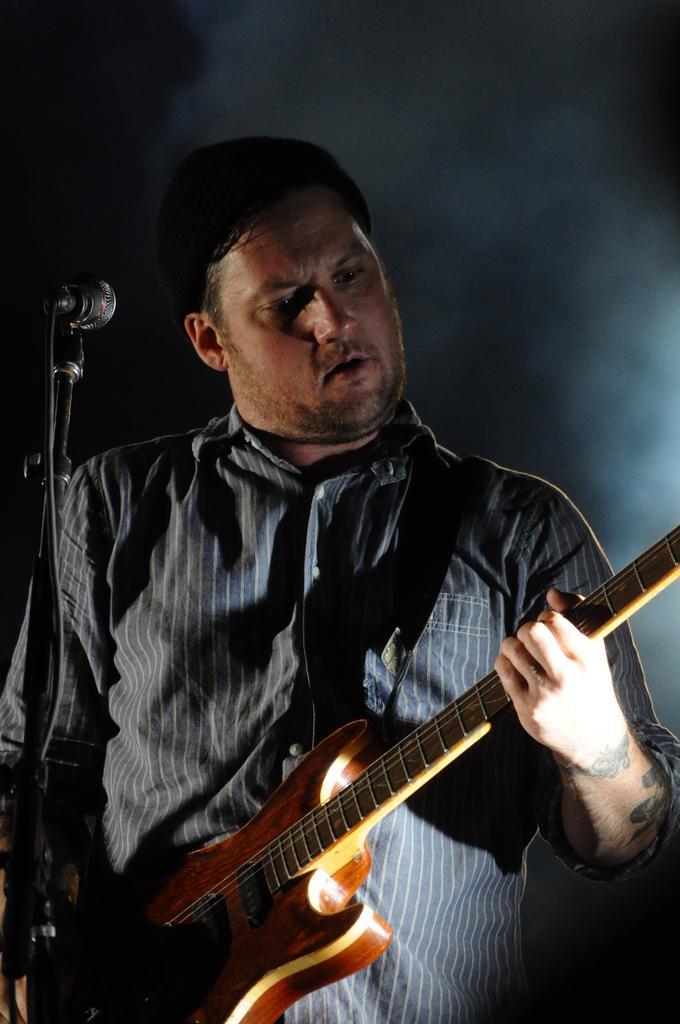Could you give a brief overview of what you see in this image? In this image i can see a man is playing a guitar in front of a microphone. 